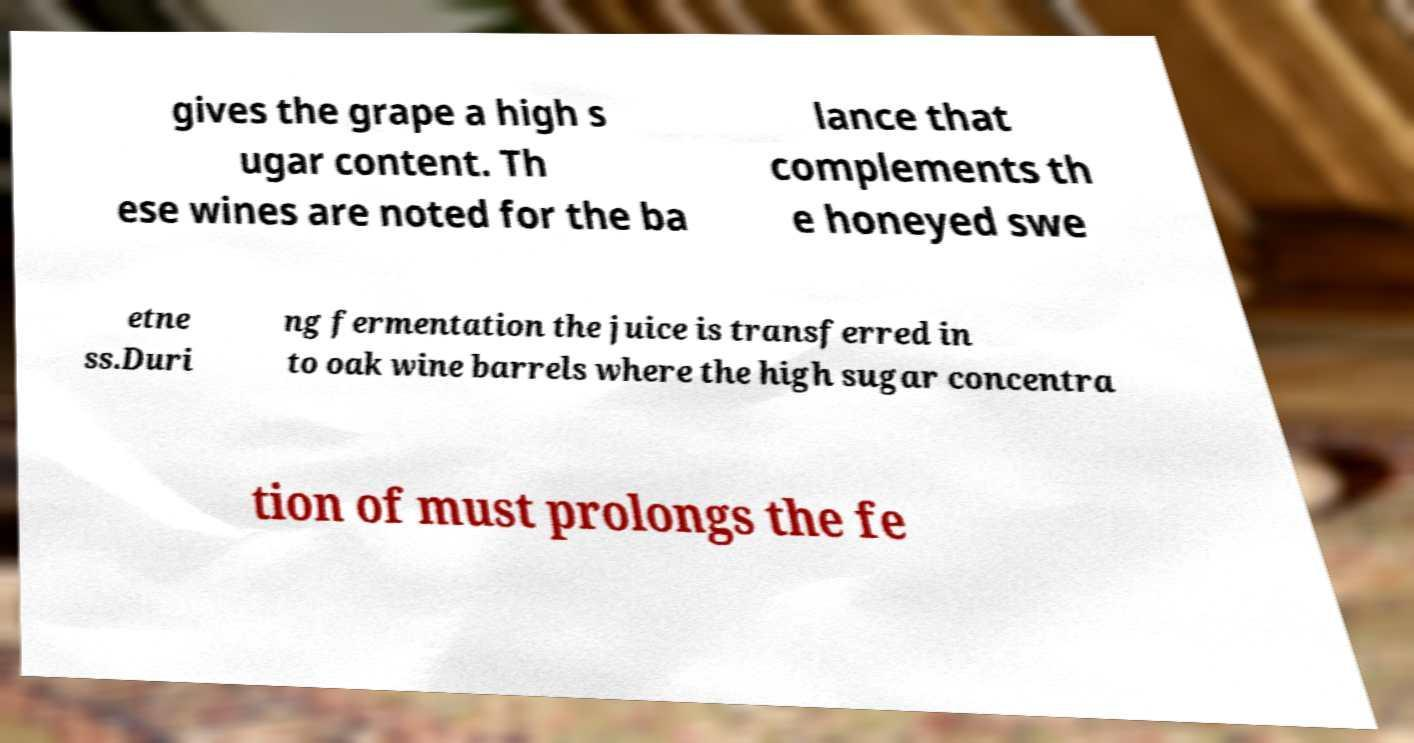Please read and relay the text visible in this image. What does it say? gives the grape a high s ugar content. Th ese wines are noted for the ba lance that complements th e honeyed swe etne ss.Duri ng fermentation the juice is transferred in to oak wine barrels where the high sugar concentra tion of must prolongs the fe 